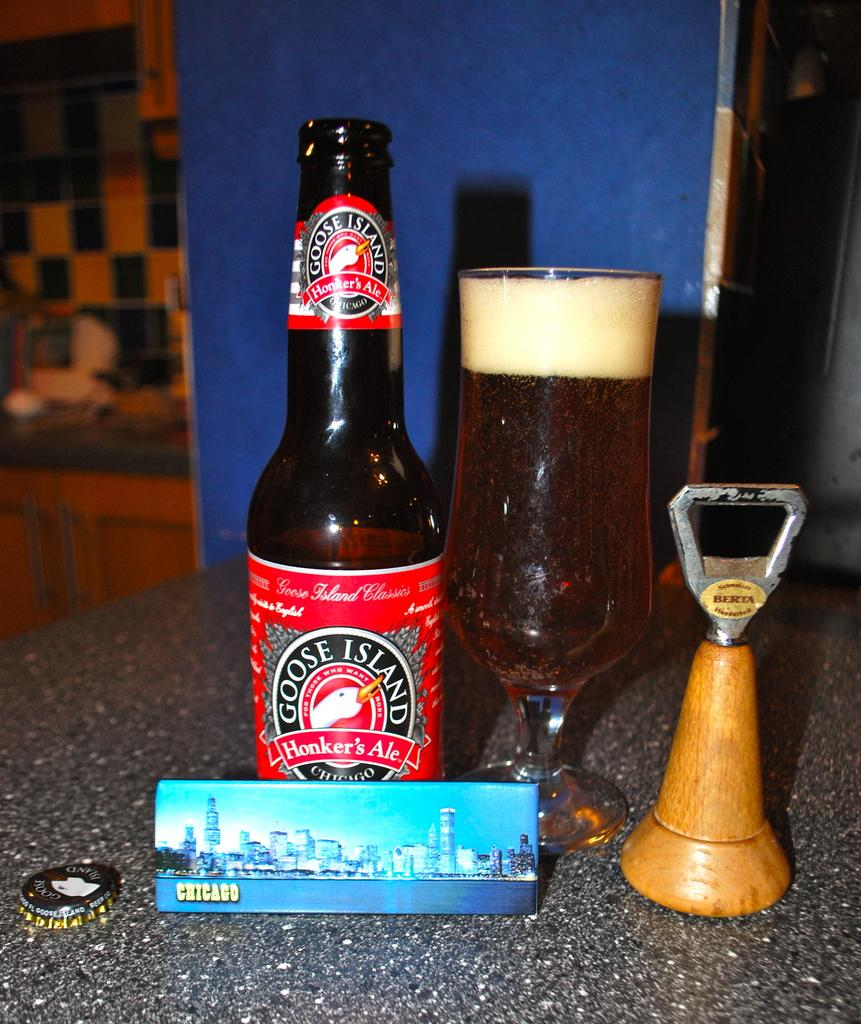Provide a one-sentence caption for the provided image. Bottle of Goose Island HOnker's Ale beside a full glass. 